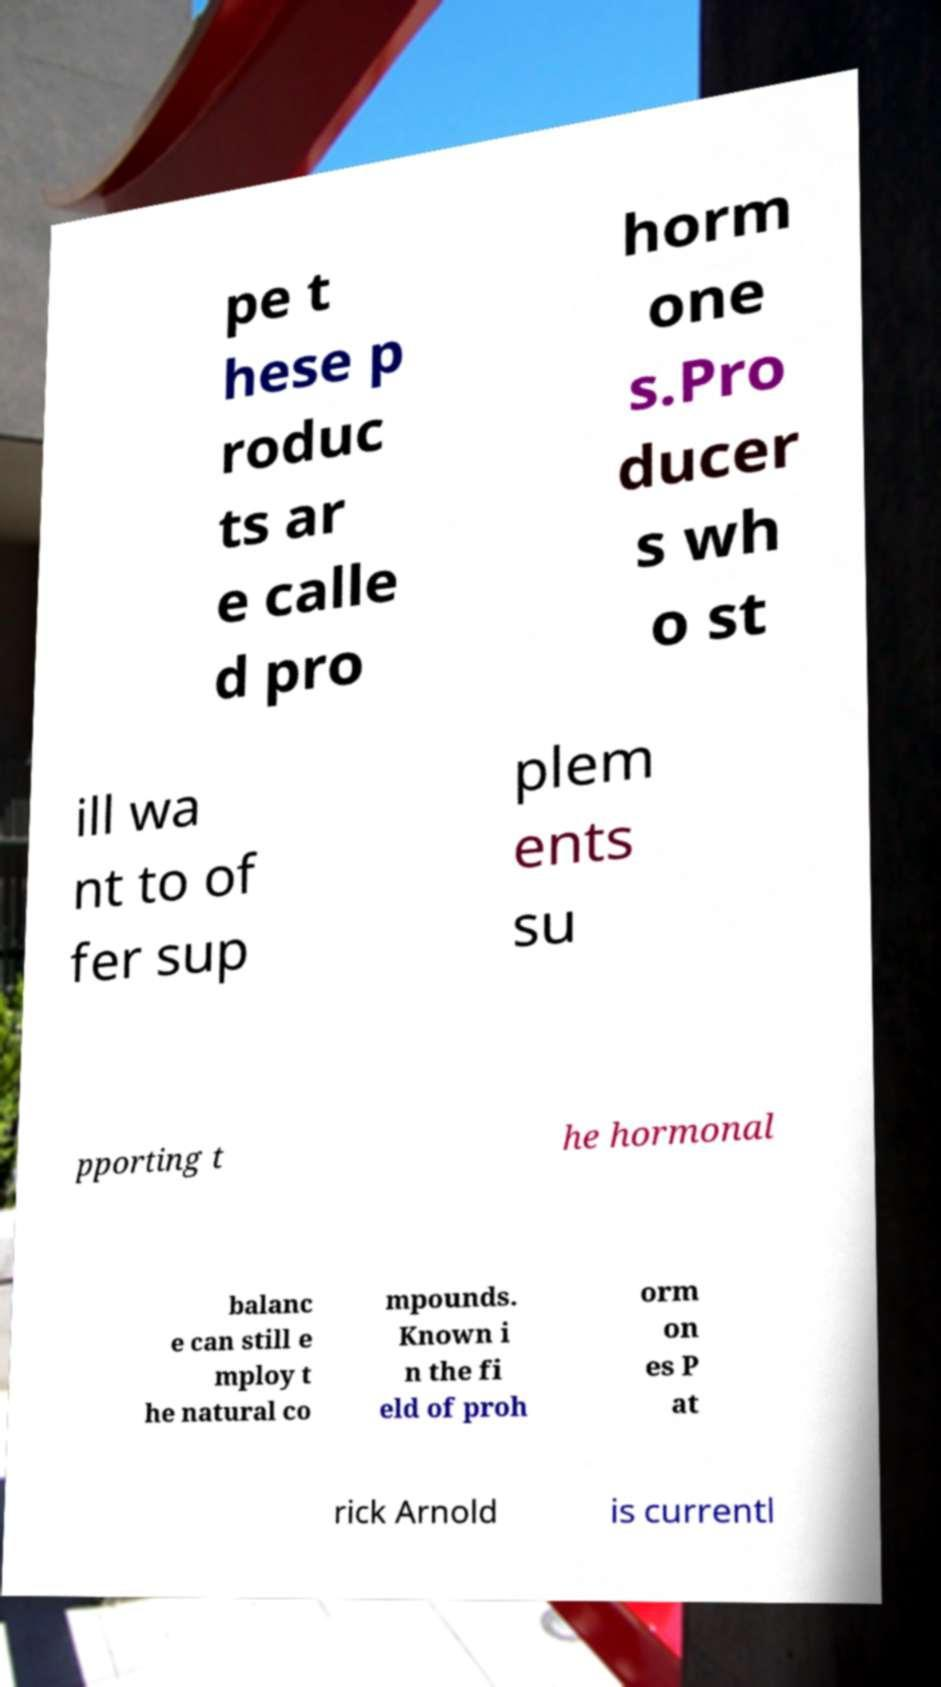I need the written content from this picture converted into text. Can you do that? pe t hese p roduc ts ar e calle d pro horm one s.Pro ducer s wh o st ill wa nt to of fer sup plem ents su pporting t he hormonal balanc e can still e mploy t he natural co mpounds. Known i n the fi eld of proh orm on es P at rick Arnold is currentl 